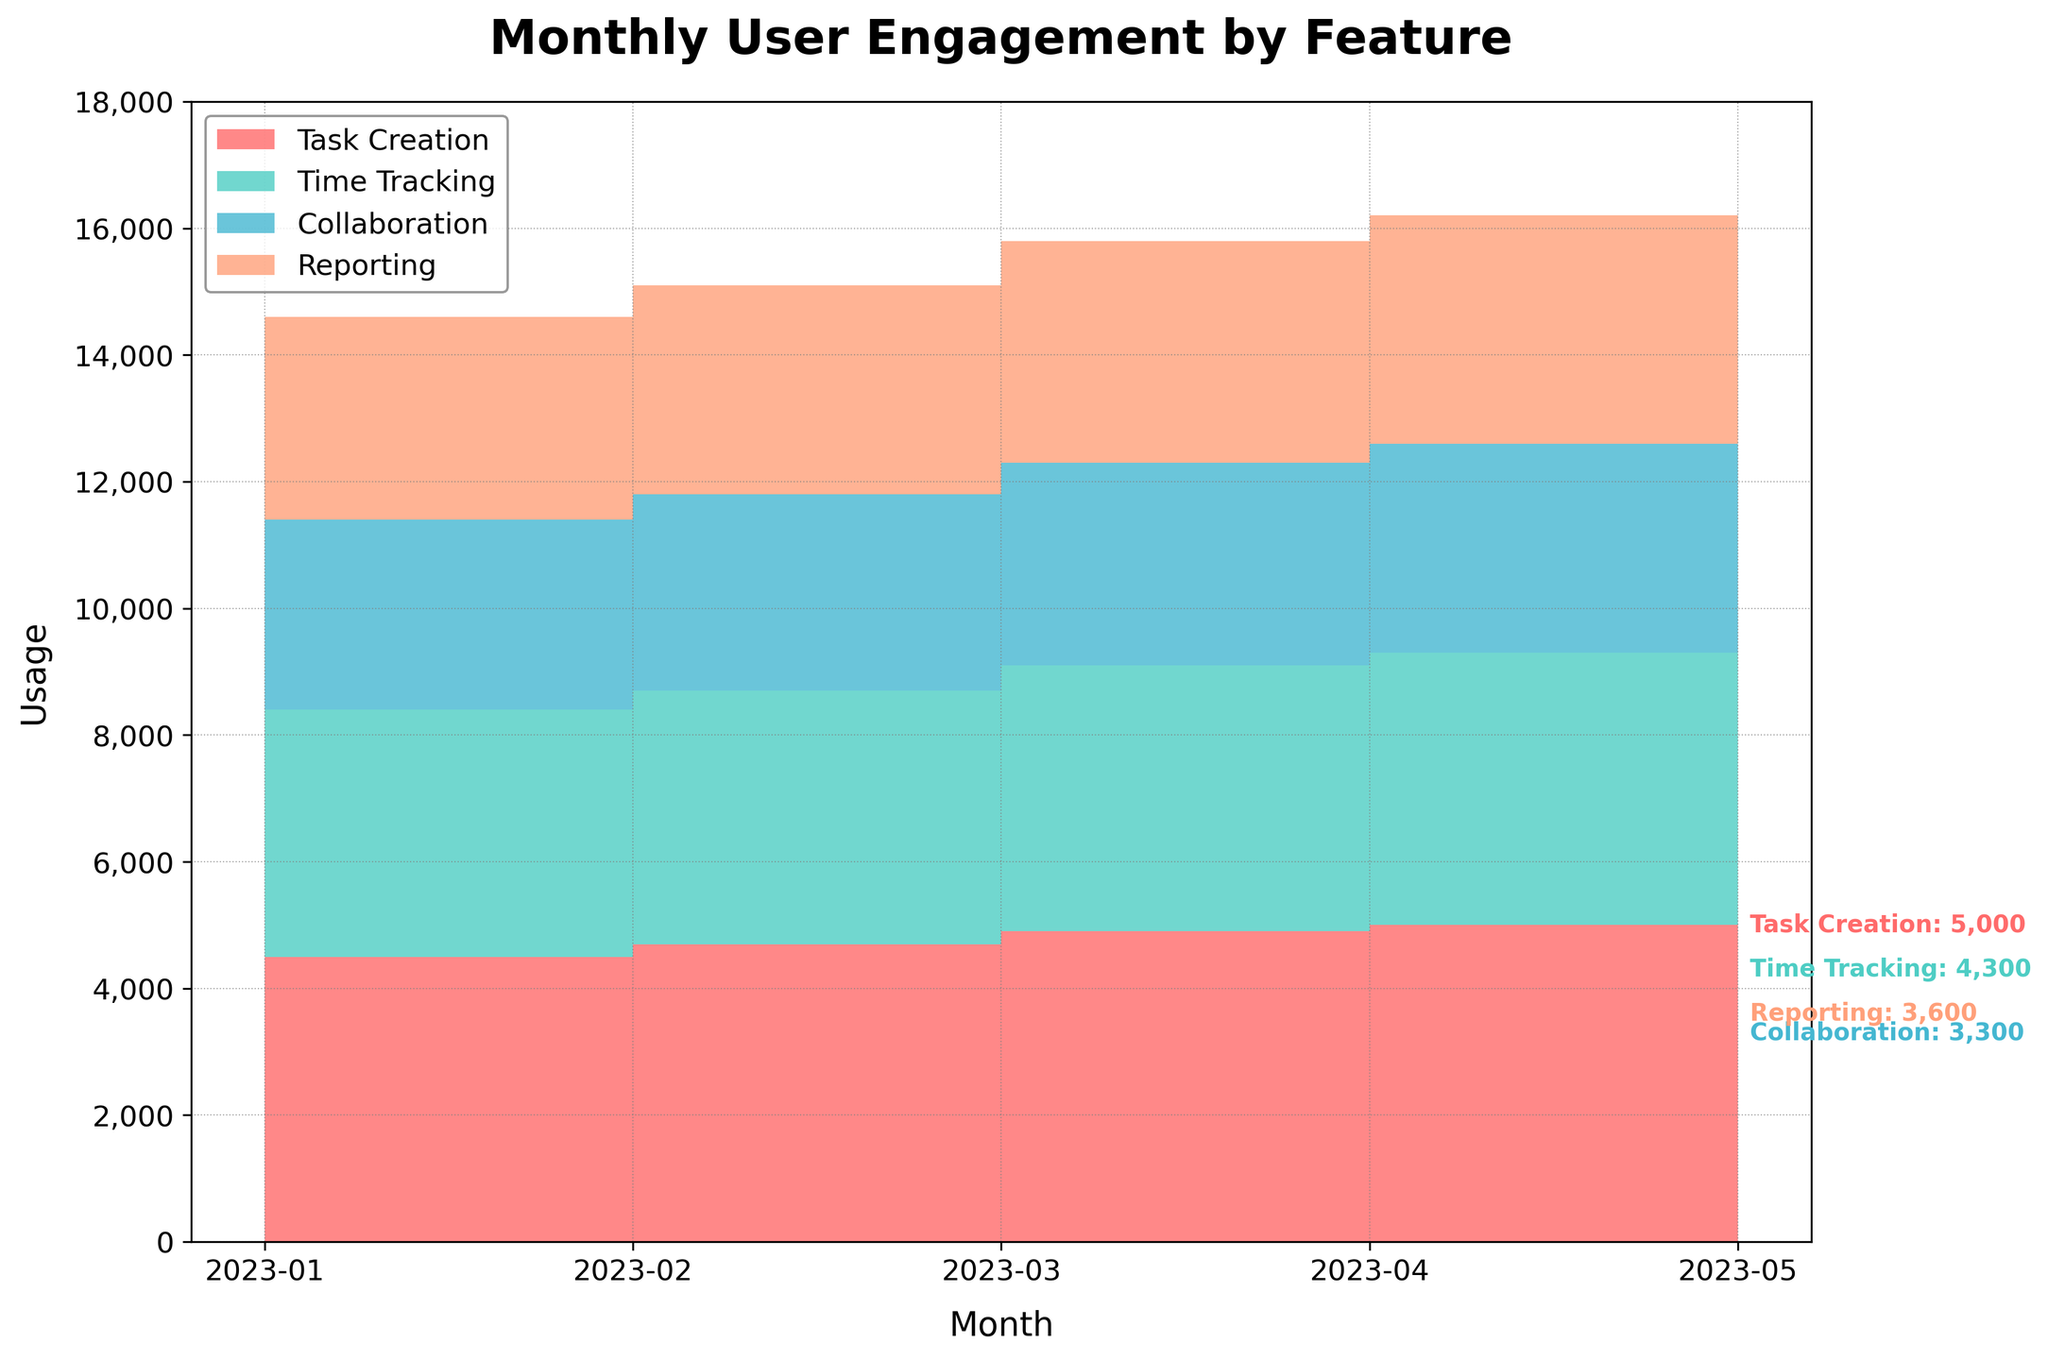What is the title of the chart? The title of the chart is displayed at the top and reads "Monthly User Engagement by Feature."
Answer: Monthly User Engagement by Feature What does the x-axis represent? The x-axis represents the months for which the data is plotted, showing from January 2023 to May 2023.
Answer: Months Which feature had the highest user engagement in May 2023? By looking at the May 2023 segment on the chart, Task Creation has the highest user engagement.
Answer: Task Creation How does the usage of Reporting change from January 2023 to May 2023? By comparing the starting and ending points for the Reporting feature, its usage increases from 3100 in January 2023 to 3600 in May 2023.
Answer: Increased from 3100 to 3600 What was the total user engagement for all features in April 2023? Adding up user engagement for all features in April: Task Creation (4900) + Time Tracking (4200) + Collaboration (3200) + Reporting (3500) = 15800.
Answer: 15800 Which feature showed the most consistent increase in user engagement from January 2023 to May 2023? From the chart, we see the Task Creation feature shows a consistent month-over-month increase.
Answer: Task Creation Did any feature consistently have lower user engagement compared to others? Collaboration consistently appears at the lowest position in the stacked area chart throughout all months, indicating lower engagement compared to other features.
Answer: Collaboration How much did Time Tracking usage increase from February 2023 to April 2023? Comparing the values from February (3900) and April (4200), Time Tracking increased by 4200 - 3900 = 300.
Answer: 300 What is the trend of usage for Collaboration feature from January to May 2023? Examining the Collaboration feature line, it shows a steady, gradual increase each month from 2900 in January to 3300 in May.
Answer: Steady increase Between Task Creation and Time Tracking, which feature had a larger increase in usage from January 2023 to May 2023? Task Creation increased from 4300 to 5000 (700) and Time Tracking from 3800 to 4300 (500). A comparison shows Task Creation had a larger increase (700 > 500).
Answer: Task Creation Which month showed the highest total user engagement across all features? By comparing the cumulative height of stacks in each month, May 2023 has the highest overall user engagement.
Answer: May 2023 